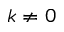<formula> <loc_0><loc_0><loc_500><loc_500>k \neq 0</formula> 